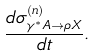Convert formula to latex. <formula><loc_0><loc_0><loc_500><loc_500>\frac { d \sigma _ { \gamma ^ { * } A \rightarrow \rho X } ^ { ( n ) } } { d t } .</formula> 